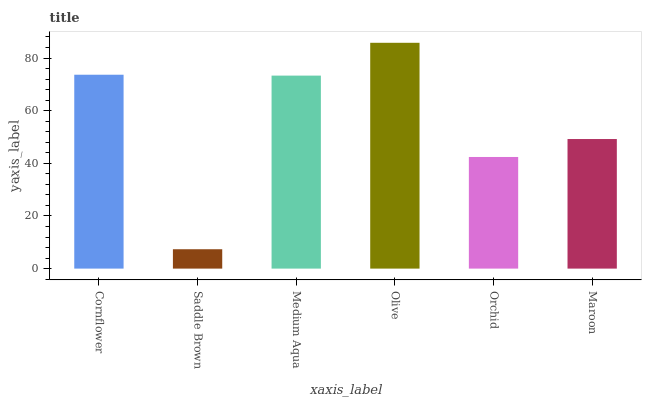Is Saddle Brown the minimum?
Answer yes or no. Yes. Is Olive the maximum?
Answer yes or no. Yes. Is Medium Aqua the minimum?
Answer yes or no. No. Is Medium Aqua the maximum?
Answer yes or no. No. Is Medium Aqua greater than Saddle Brown?
Answer yes or no. Yes. Is Saddle Brown less than Medium Aqua?
Answer yes or no. Yes. Is Saddle Brown greater than Medium Aqua?
Answer yes or no. No. Is Medium Aqua less than Saddle Brown?
Answer yes or no. No. Is Medium Aqua the high median?
Answer yes or no. Yes. Is Maroon the low median?
Answer yes or no. Yes. Is Orchid the high median?
Answer yes or no. No. Is Medium Aqua the low median?
Answer yes or no. No. 